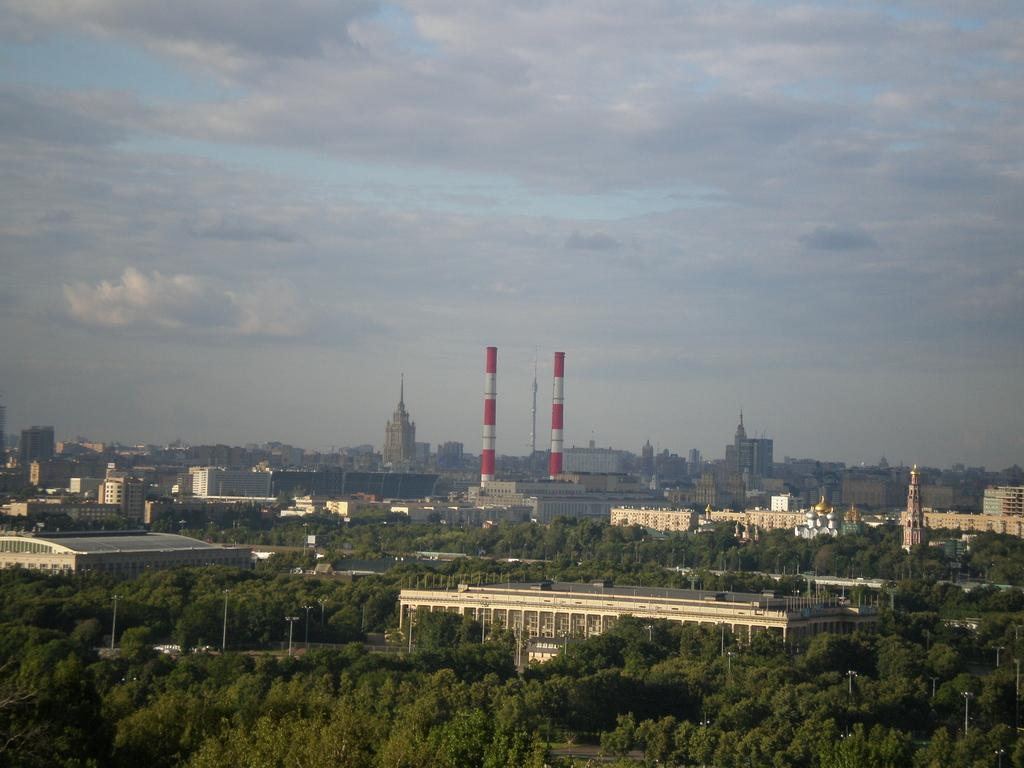What type of natural elements surround the buildings in the image? There are many trees around the buildings in the image. What structures can be seen in the background of the image? There are two lighthouses in the background of the image. What can be observed in the sky in the image? Clouds and the sky are visible in the background of the image. How many boats are visible in the image? There are no boats present in the image. What type of stamp is featured on the lighthouses in the image? There is no stamp present on the lighthouses in the image. 